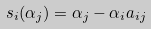Convert formula to latex. <formula><loc_0><loc_0><loc_500><loc_500>s _ { i } ( \alpha _ { j } ) = \alpha _ { j } - \alpha _ { i } a _ { i j }</formula> 